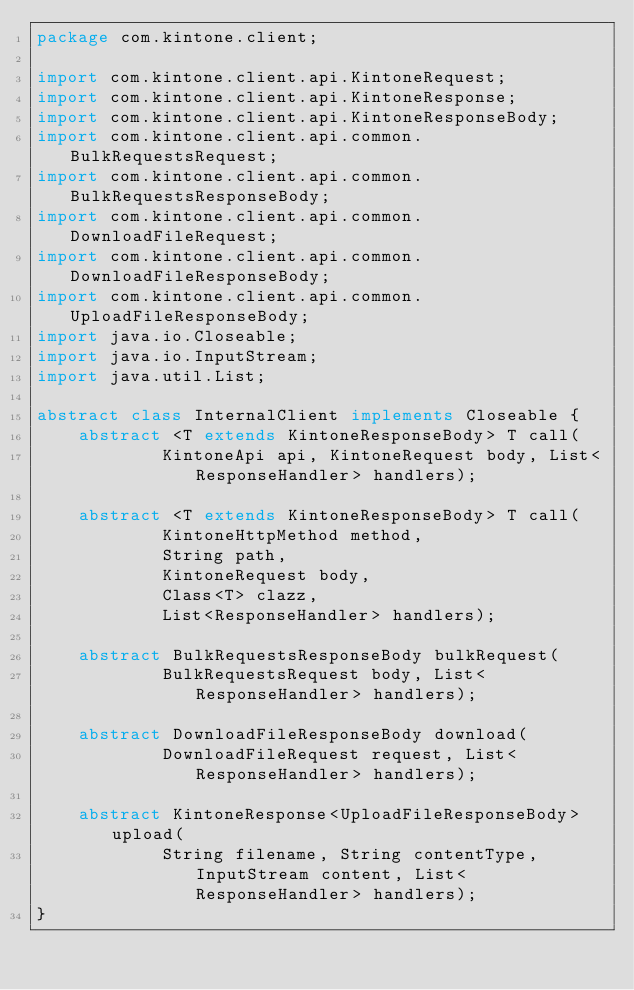<code> <loc_0><loc_0><loc_500><loc_500><_Java_>package com.kintone.client;

import com.kintone.client.api.KintoneRequest;
import com.kintone.client.api.KintoneResponse;
import com.kintone.client.api.KintoneResponseBody;
import com.kintone.client.api.common.BulkRequestsRequest;
import com.kintone.client.api.common.BulkRequestsResponseBody;
import com.kintone.client.api.common.DownloadFileRequest;
import com.kintone.client.api.common.DownloadFileResponseBody;
import com.kintone.client.api.common.UploadFileResponseBody;
import java.io.Closeable;
import java.io.InputStream;
import java.util.List;

abstract class InternalClient implements Closeable {
    abstract <T extends KintoneResponseBody> T call(
            KintoneApi api, KintoneRequest body, List<ResponseHandler> handlers);

    abstract <T extends KintoneResponseBody> T call(
            KintoneHttpMethod method,
            String path,
            KintoneRequest body,
            Class<T> clazz,
            List<ResponseHandler> handlers);

    abstract BulkRequestsResponseBody bulkRequest(
            BulkRequestsRequest body, List<ResponseHandler> handlers);

    abstract DownloadFileResponseBody download(
            DownloadFileRequest request, List<ResponseHandler> handlers);

    abstract KintoneResponse<UploadFileResponseBody> upload(
            String filename, String contentType, InputStream content, List<ResponseHandler> handlers);
}
</code> 